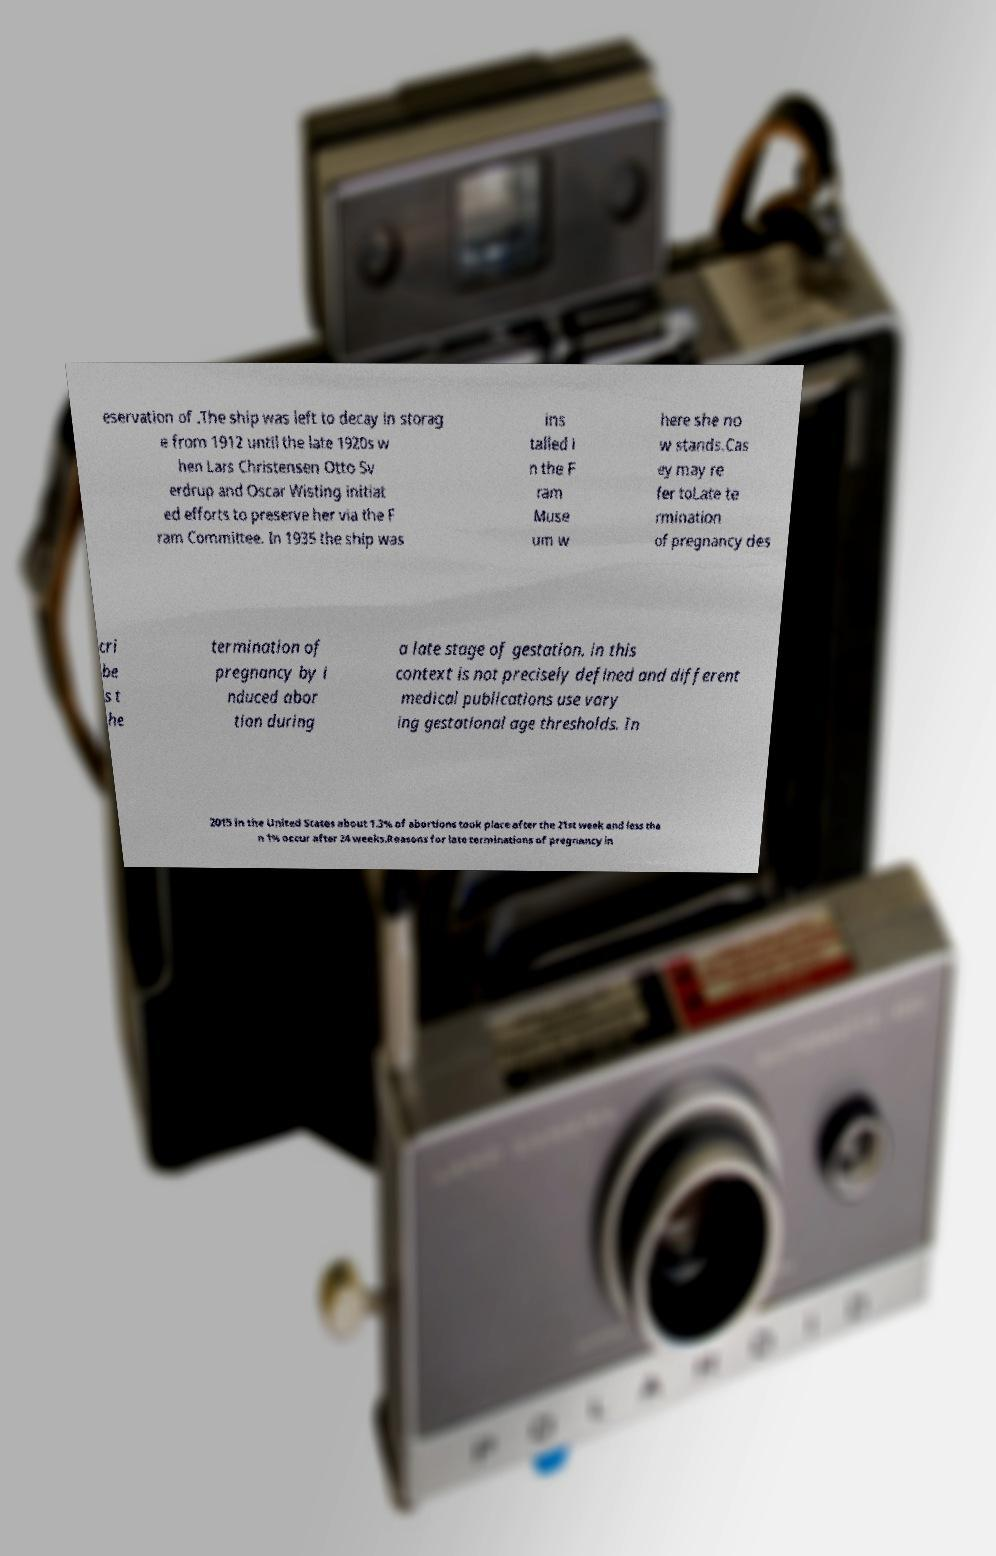Can you read and provide the text displayed in the image?This photo seems to have some interesting text. Can you extract and type it out for me? eservation of .The ship was left to decay in storag e from 1912 until the late 1920s w hen Lars Christensen Otto Sv erdrup and Oscar Wisting initiat ed efforts to preserve her via the F ram Committee. In 1935 the ship was ins talled i n the F ram Muse um w here she no w stands.Cas ey may re fer toLate te rmination of pregnancy des cri be s t he termination of pregnancy by i nduced abor tion during a late stage of gestation. in this context is not precisely defined and different medical publications use vary ing gestational age thresholds. In 2015 in the United States about 1.3% of abortions took place after the 21st week and less tha n 1% occur after 24 weeks.Reasons for late terminations of pregnancy in 